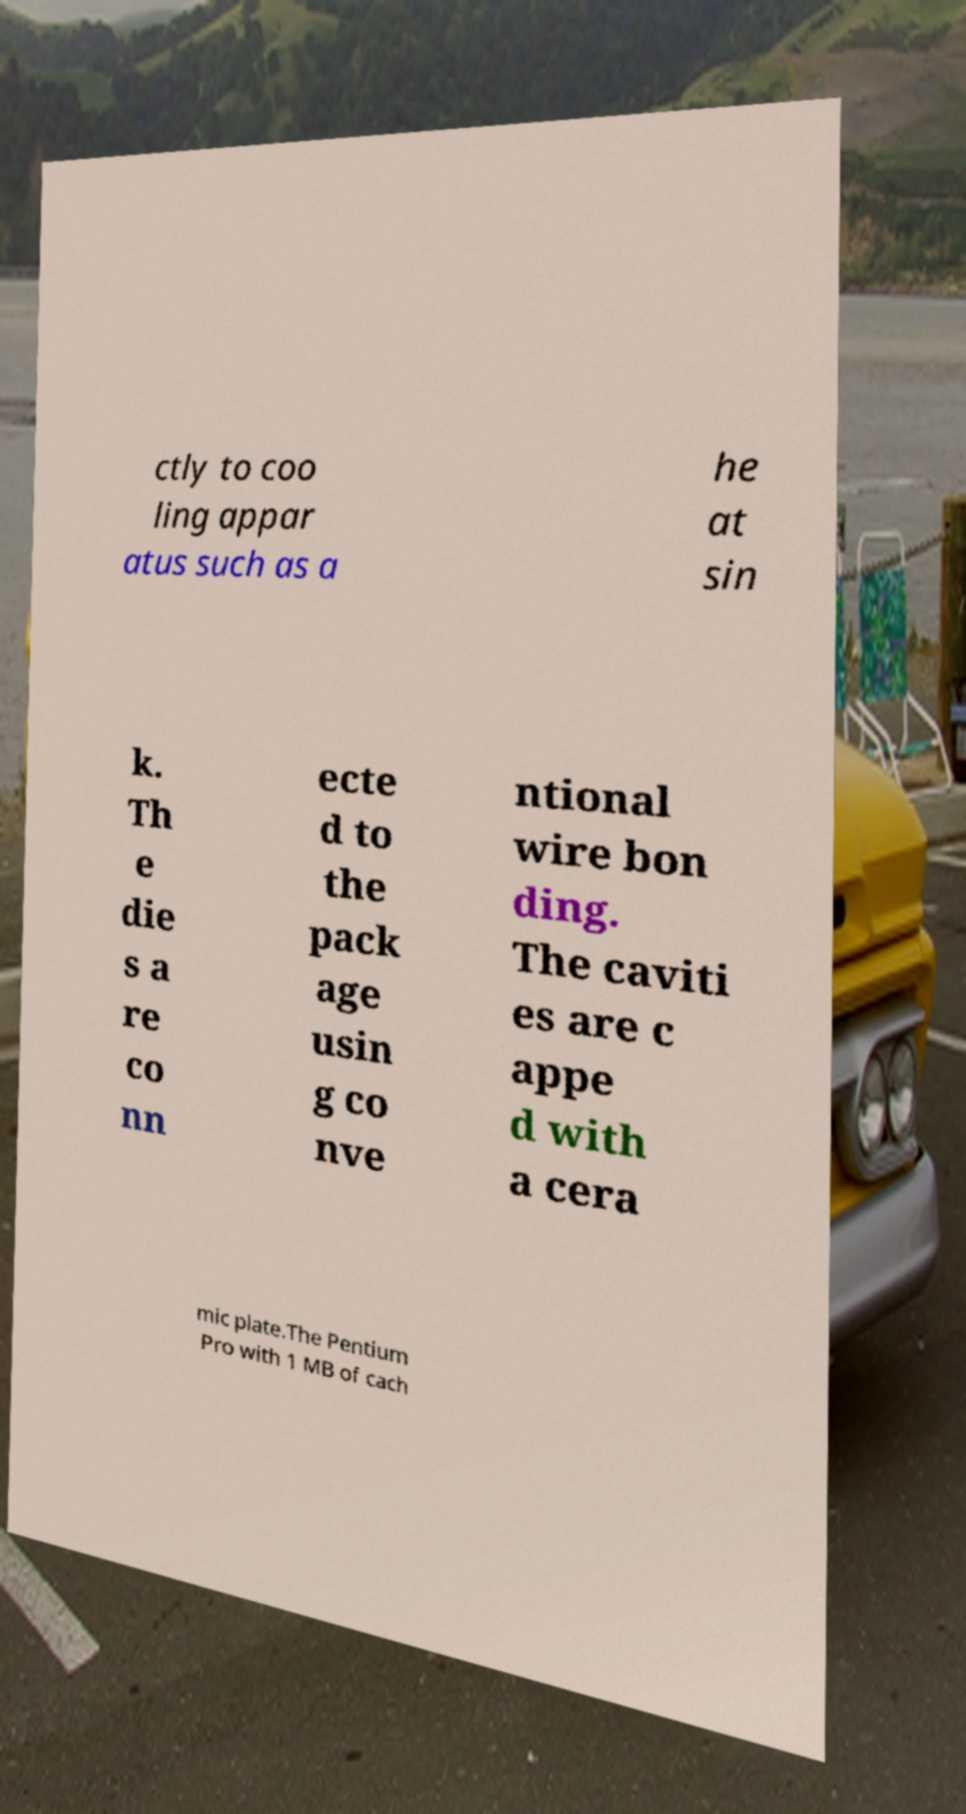Can you accurately transcribe the text from the provided image for me? ctly to coo ling appar atus such as a he at sin k. Th e die s a re co nn ecte d to the pack age usin g co nve ntional wire bon ding. The caviti es are c appe d with a cera mic plate.The Pentium Pro with 1 MB of cach 